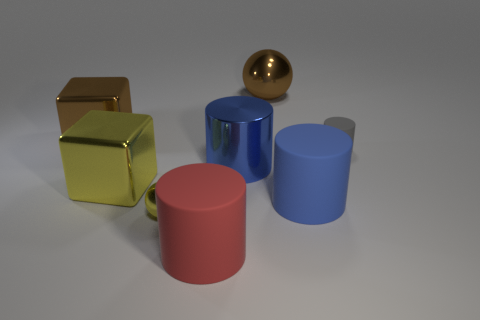Is there any other thing that is the same color as the small cylinder?
Offer a very short reply. No. What is the size of the sphere that is in front of the big brown metal thing that is to the right of the big metallic block behind the blue shiny object?
Offer a terse response. Small. The big rubber cylinder in front of the sphere that is to the left of the big brown metallic ball is what color?
Make the answer very short. Red. There is another tiny thing that is the same shape as the red object; what is it made of?
Your answer should be compact. Rubber. There is a large red rubber cylinder; are there any matte things on the right side of it?
Provide a succinct answer. Yes. How many yellow balls are there?
Provide a succinct answer. 1. There is a metallic block that is behind the tiny gray object; what number of tiny metal balls are on the right side of it?
Offer a very short reply. 1. Does the large ball have the same color as the large metallic block that is behind the large blue shiny cylinder?
Your response must be concise. Yes. How many large blue objects have the same shape as the small matte thing?
Ensure brevity in your answer.  2. There is a big blue object that is on the right side of the large blue metal cylinder; what is it made of?
Make the answer very short. Rubber. 